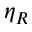<formula> <loc_0><loc_0><loc_500><loc_500>\eta _ { R }</formula> 